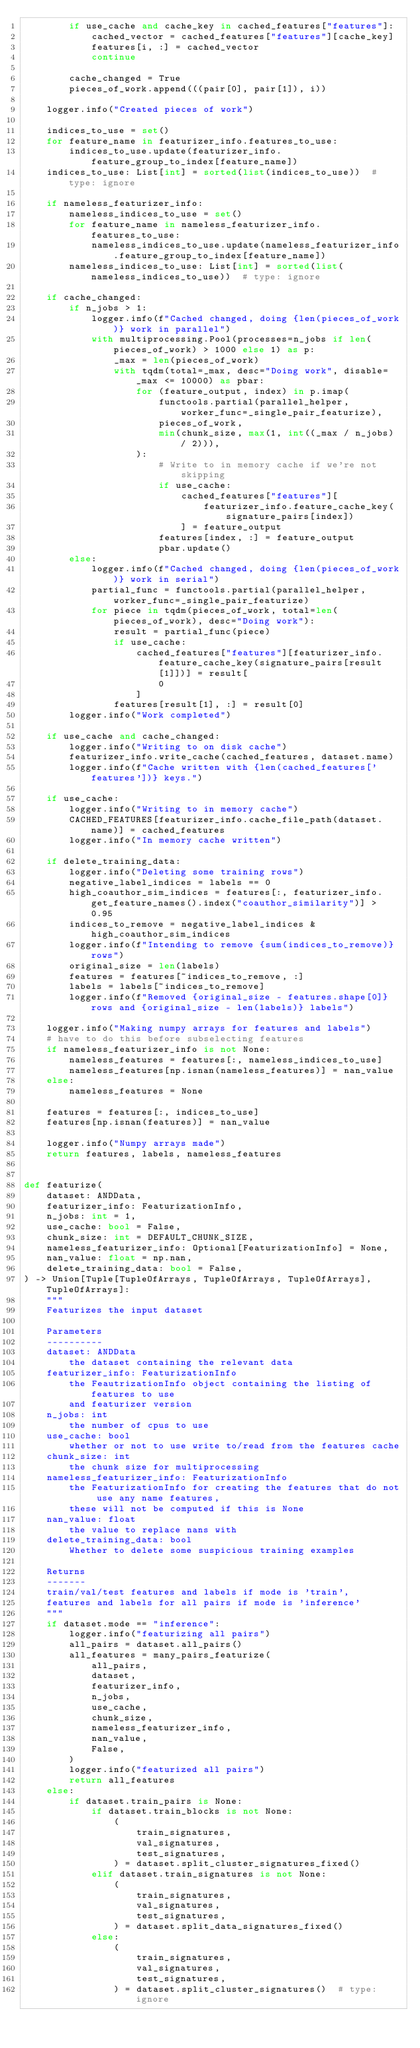<code> <loc_0><loc_0><loc_500><loc_500><_Python_>        if use_cache and cache_key in cached_features["features"]:
            cached_vector = cached_features["features"][cache_key]
            features[i, :] = cached_vector
            continue

        cache_changed = True
        pieces_of_work.append(((pair[0], pair[1]), i))

    logger.info("Created pieces of work")

    indices_to_use = set()
    for feature_name in featurizer_info.features_to_use:
        indices_to_use.update(featurizer_info.feature_group_to_index[feature_name])
    indices_to_use: List[int] = sorted(list(indices_to_use))  # type: ignore

    if nameless_featurizer_info:
        nameless_indices_to_use = set()
        for feature_name in nameless_featurizer_info.features_to_use:
            nameless_indices_to_use.update(nameless_featurizer_info.feature_group_to_index[feature_name])
        nameless_indices_to_use: List[int] = sorted(list(nameless_indices_to_use))  # type: ignore

    if cache_changed:
        if n_jobs > 1:
            logger.info(f"Cached changed, doing {len(pieces_of_work)} work in parallel")
            with multiprocessing.Pool(processes=n_jobs if len(pieces_of_work) > 1000 else 1) as p:
                _max = len(pieces_of_work)
                with tqdm(total=_max, desc="Doing work", disable=_max <= 10000) as pbar:
                    for (feature_output, index) in p.imap(
                        functools.partial(parallel_helper, worker_func=_single_pair_featurize),
                        pieces_of_work,
                        min(chunk_size, max(1, int((_max / n_jobs) / 2))),
                    ):
                        # Write to in memory cache if we're not skipping
                        if use_cache:
                            cached_features["features"][
                                featurizer_info.feature_cache_key(signature_pairs[index])
                            ] = feature_output
                        features[index, :] = feature_output
                        pbar.update()
        else:
            logger.info(f"Cached changed, doing {len(pieces_of_work)} work in serial")
            partial_func = functools.partial(parallel_helper, worker_func=_single_pair_featurize)
            for piece in tqdm(pieces_of_work, total=len(pieces_of_work), desc="Doing work"):
                result = partial_func(piece)
                if use_cache:
                    cached_features["features"][featurizer_info.feature_cache_key(signature_pairs[result[1]])] = result[
                        0
                    ]
                features[result[1], :] = result[0]
        logger.info("Work completed")

    if use_cache and cache_changed:
        logger.info("Writing to on disk cache")
        featurizer_info.write_cache(cached_features, dataset.name)
        logger.info(f"Cache written with {len(cached_features['features'])} keys.")

    if use_cache:
        logger.info("Writing to in memory cache")
        CACHED_FEATURES[featurizer_info.cache_file_path(dataset.name)] = cached_features
        logger.info("In memory cache written")

    if delete_training_data:
        logger.info("Deleting some training rows")
        negative_label_indices = labels == 0
        high_coauthor_sim_indices = features[:, featurizer_info.get_feature_names().index("coauthor_similarity")] > 0.95
        indices_to_remove = negative_label_indices & high_coauthor_sim_indices
        logger.info(f"Intending to remove {sum(indices_to_remove)} rows")
        original_size = len(labels)
        features = features[~indices_to_remove, :]
        labels = labels[~indices_to_remove]
        logger.info(f"Removed {original_size - features.shape[0]} rows and {original_size - len(labels)} labels")

    logger.info("Making numpy arrays for features and labels")
    # have to do this before subselecting features
    if nameless_featurizer_info is not None:
        nameless_features = features[:, nameless_indices_to_use]
        nameless_features[np.isnan(nameless_features)] = nan_value
    else:
        nameless_features = None

    features = features[:, indices_to_use]
    features[np.isnan(features)] = nan_value

    logger.info("Numpy arrays made")
    return features, labels, nameless_features


def featurize(
    dataset: ANDData,
    featurizer_info: FeaturizationInfo,
    n_jobs: int = 1,
    use_cache: bool = False,
    chunk_size: int = DEFAULT_CHUNK_SIZE,
    nameless_featurizer_info: Optional[FeaturizationInfo] = None,
    nan_value: float = np.nan,
    delete_training_data: bool = False,
) -> Union[Tuple[TupleOfArrays, TupleOfArrays, TupleOfArrays], TupleOfArrays]:
    """
    Featurizes the input dataset

    Parameters
    ----------
    dataset: ANDData
        the dataset containing the relevant data
    featurizer_info: FeaturizationInfo
        the FeautrizationInfo object containing the listing of features to use
        and featurizer version
    n_jobs: int
        the number of cpus to use
    use_cache: bool
        whether or not to use write to/read from the features cache
    chunk_size: int
        the chunk size for multiprocessing
    nameless_featurizer_info: FeaturizationInfo
        the FeaturizationInfo for creating the features that do not use any name features,
        these will not be computed if this is None
    nan_value: float
        the value to replace nans with
    delete_training_data: bool
        Whether to delete some suspicious training examples

    Returns
    -------
    train/val/test features and labels if mode is 'train',
    features and labels for all pairs if mode is 'inference'
    """
    if dataset.mode == "inference":
        logger.info("featurizing all pairs")
        all_pairs = dataset.all_pairs()
        all_features = many_pairs_featurize(
            all_pairs,
            dataset,
            featurizer_info,
            n_jobs,
            use_cache,
            chunk_size,
            nameless_featurizer_info,
            nan_value,
            False,
        )
        logger.info("featurized all pairs")
        return all_features
    else:
        if dataset.train_pairs is None:
            if dataset.train_blocks is not None:
                (
                    train_signatures,
                    val_signatures,
                    test_signatures,
                ) = dataset.split_cluster_signatures_fixed()
            elif dataset.train_signatures is not None:
                (
                    train_signatures,
                    val_signatures,
                    test_signatures,
                ) = dataset.split_data_signatures_fixed()
            else:
                (
                    train_signatures,
                    val_signatures,
                    test_signatures,
                ) = dataset.split_cluster_signatures()  # type: ignore
</code> 